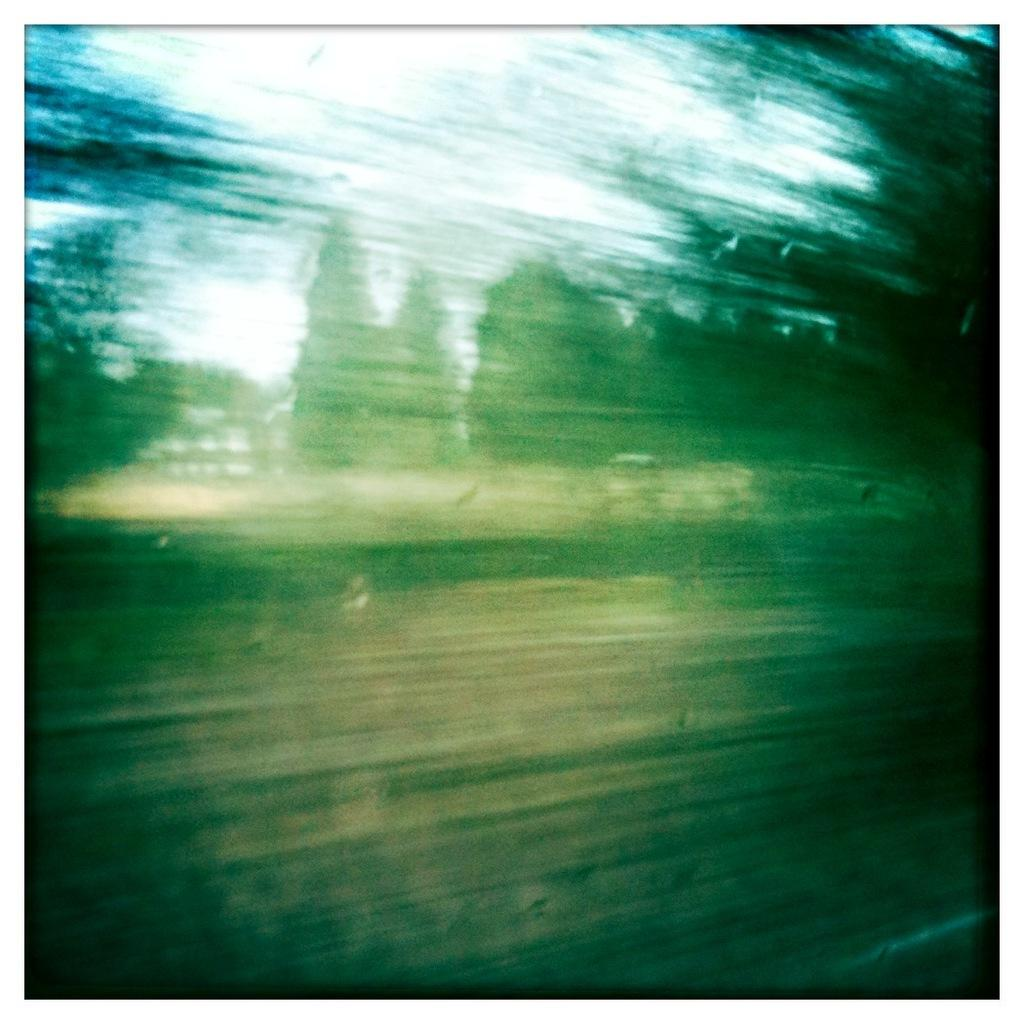What type of vegetation can be seen in the image? There are trees in the image. What color are the trees? The trees are green in color. What else is visible in the image besides the trees? There is a sky in the image. What color is the sky? The sky is white in color. What type of property does the queen own in the image? There is no queen or property present in the image; it only features trees and a white sky. What kind of yarn is being used to knit a scarf in the image? There is no yarn or knitting activity present in the image. 